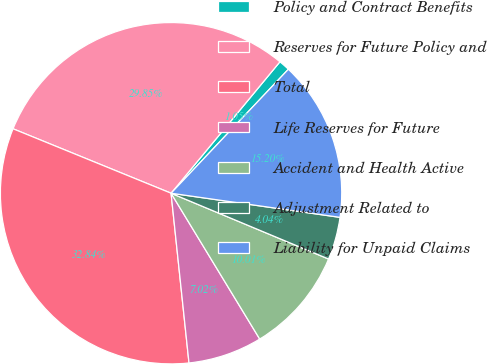<chart> <loc_0><loc_0><loc_500><loc_500><pie_chart><fcel>Policy and Contract Benefits<fcel>Reserves for Future Policy and<fcel>Total<fcel>Life Reserves for Future<fcel>Accident and Health Active<fcel>Adjustment Related to<fcel>Liability for Unpaid Claims<nl><fcel>1.05%<fcel>29.85%<fcel>32.84%<fcel>7.02%<fcel>10.01%<fcel>4.04%<fcel>15.2%<nl></chart> 